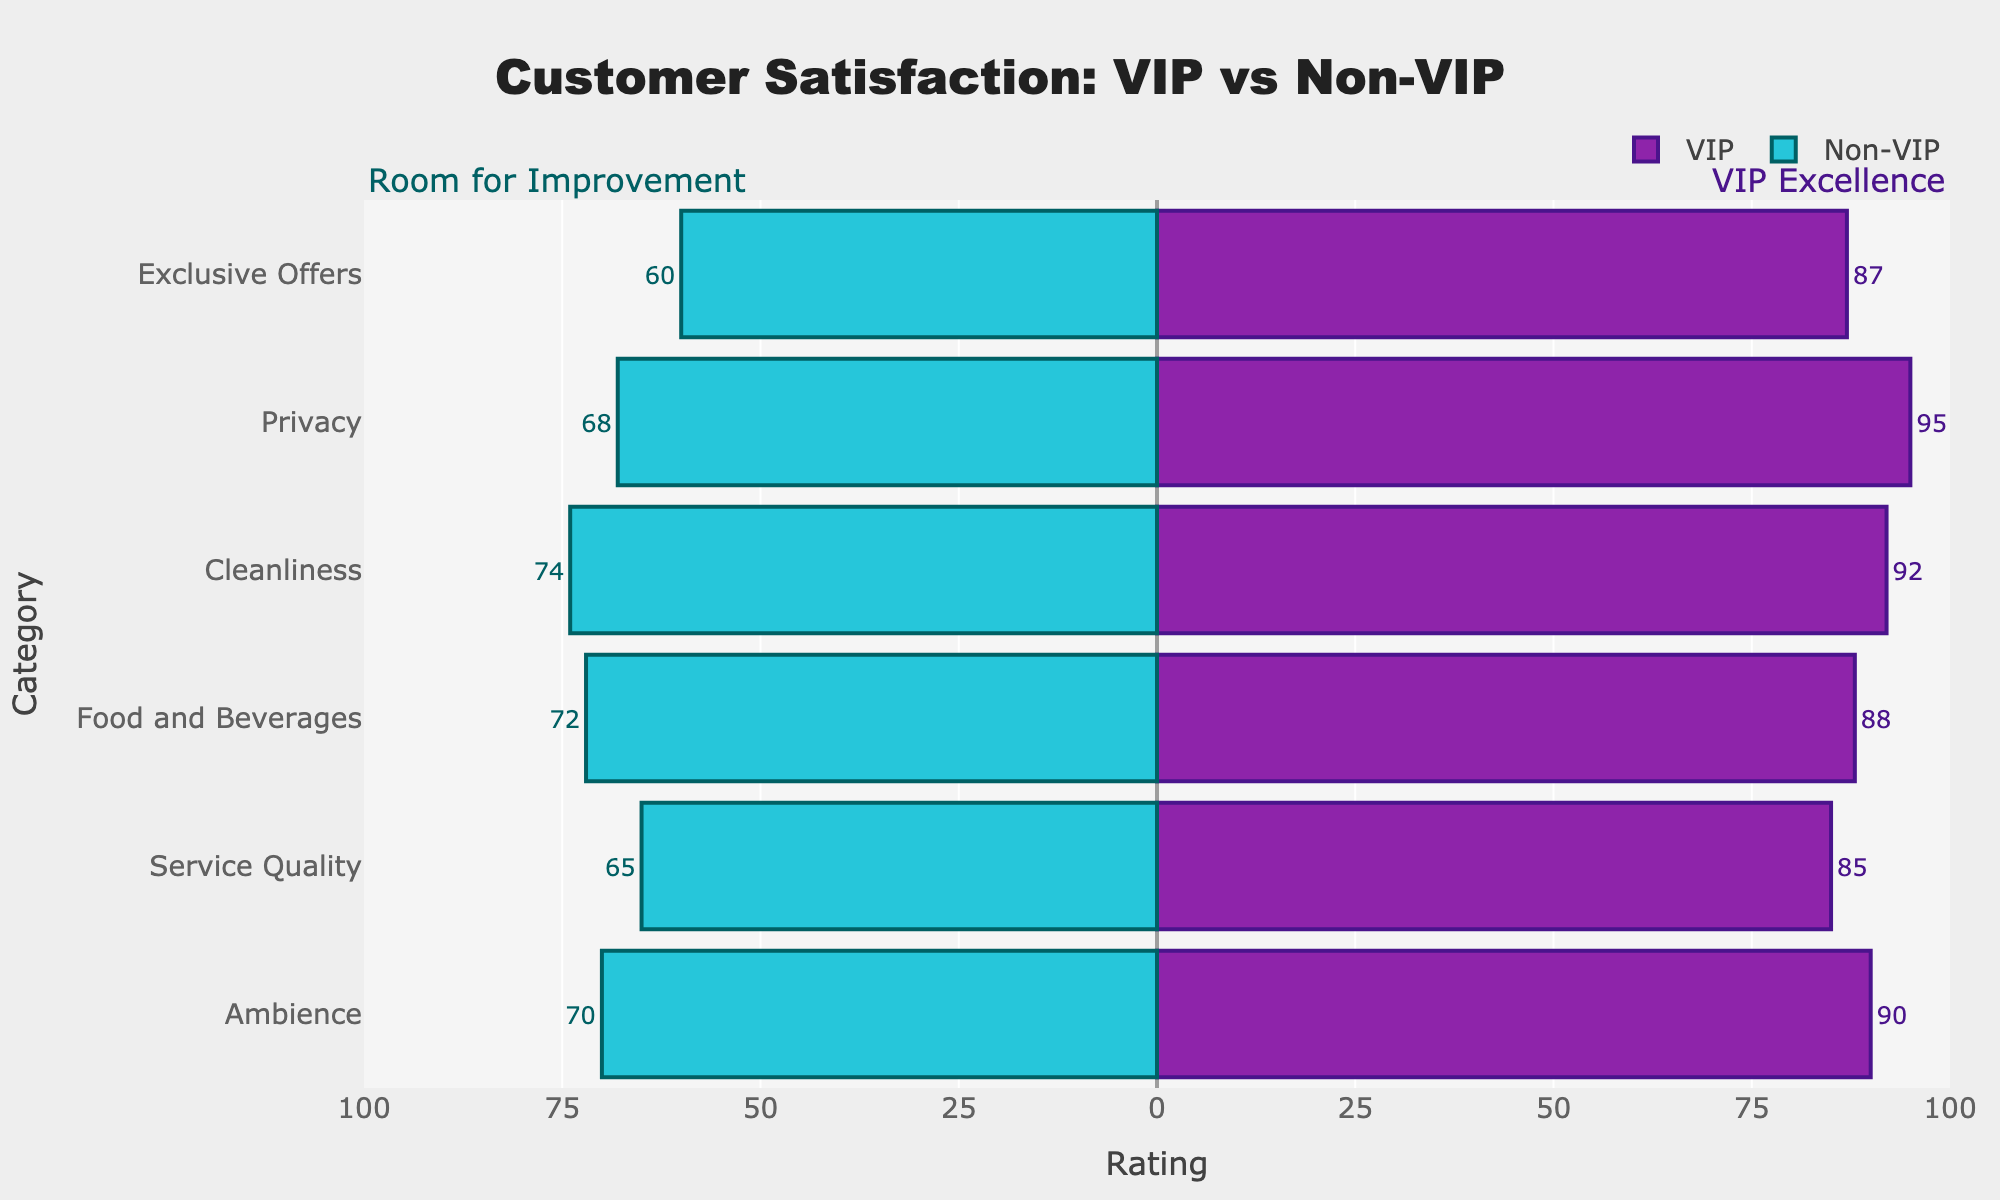Which category has the highest satisfaction rating among VIPs? By looking at the length of the purple bars on the right side, we can identify that the category 'Privacy' has the highest satisfaction rating among VIPs at 95.
Answer: Privacy Which category exhibits the largest difference in satisfaction ratings between VIPs and Non-VIPs? Calculate the difference in ratings for each category, noting that Privacy has a rating difference of 95 - 68 = 27, which is the largest among all categories.
Answer: Privacy What is the average satisfaction rating for Non-VIPs across all categories? Add up all the Non-VIP ratings and divide by the number of categories: (70 + 65 + 72 + 74 + 68 + 60) / 6 = 68.17.
Answer: 68.17 Which group shows lower ratings for the 'Ambience' category? By comparing the lengths of the bars labeled 'Ambience', the Non-VIP group has a shorter (or leftward) bar with a rating of 70, while VIPs have a rating of 90.
Answer: Non-VIPs By how many points does the VIP satisfaction rating for 'Service Quality' exceed that of Non-VIPs? The VIP rating for 'Service Quality' is 85, and the Non-VIP rating is 65. The difference is 85 - 65 = 20 points.
Answer: 20 Which data type has the most uniform rating across all categories, VIPs or Non-VIPs? Visual inspection of the consistency and length of the bars shows that VIP ratings vary less widely than Non-VIP ratings across the categories, which indicates a more uniform rating pattern.
Answer: VIPs How many categories have satisfaction ratings of 85 or higher for VIPs? Checking the ratings for each category, we see that 'Ambience' (90), 'Service Quality' (85), 'Food and Beverages' (88), 'Cleanliness' (92), 'Privacy' (95), and 'Exclusive Offers' (87) all meet the criteria. Count these ratings to get 6 categories.
Answer: 6 What is the overall difference in total satisfaction scores for VIPs and Non-VIPs? Sum the ratings for each group: VIP (90 + 85 + 88 + 92 + 95 + 87 = 537) and Non-VIP (70 + 65 + 72 + 74 + 68 + 60 = 409). The difference is 537 - 409 = 128.
Answer: 128 Which of the categories shows the smallest satisfaction gap between VIPs and Non-VIPs? Calculate the differences for each category: 'Ambience' has 20, 'Service Quality' has 20, 'Food and Beverages' has 16, 'Cleanliness' has 18, 'Privacy' has 27, and 'Exclusive Offers' has 27. 'Food and Beverages' has the smallest difference at 16.
Answer: Food and Beverages What is the combined rating for both VIP and Non-VIP groups in the 'Cleanliness' category? Add the ratings for VIPs (92) and Non-VIPs (74) in the 'Cleanliness' category to get 92 + 74 = 166.
Answer: 166 